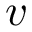<formula> <loc_0><loc_0><loc_500><loc_500>v</formula> 